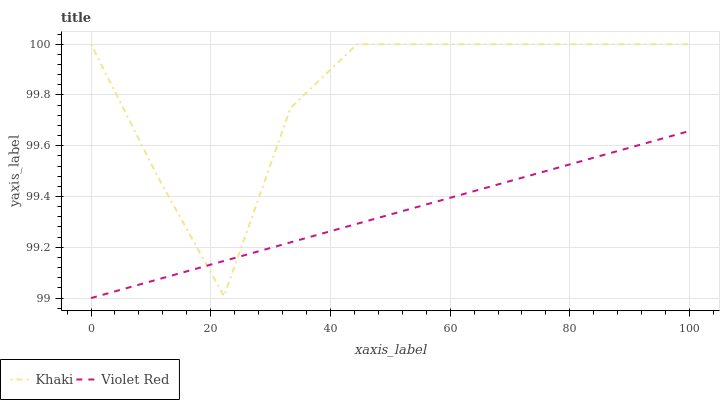Does Violet Red have the minimum area under the curve?
Answer yes or no. Yes. Does Khaki have the maximum area under the curve?
Answer yes or no. Yes. Does Khaki have the minimum area under the curve?
Answer yes or no. No. Is Violet Red the smoothest?
Answer yes or no. Yes. Is Khaki the roughest?
Answer yes or no. Yes. Is Khaki the smoothest?
Answer yes or no. No. Does Violet Red have the lowest value?
Answer yes or no. Yes. Does Khaki have the lowest value?
Answer yes or no. No. Does Khaki have the highest value?
Answer yes or no. Yes. Does Violet Red intersect Khaki?
Answer yes or no. Yes. Is Violet Red less than Khaki?
Answer yes or no. No. Is Violet Red greater than Khaki?
Answer yes or no. No. 